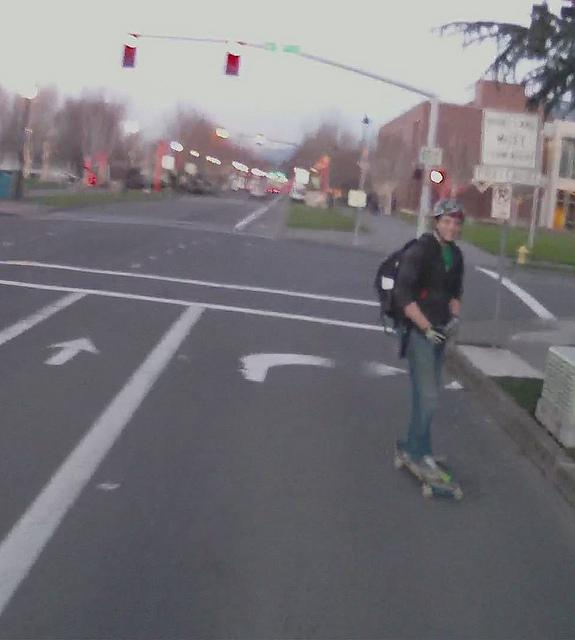A car turning which way is a hazard to this man?

Choices:
A) reversing
B) straight
C) left
D) right right 